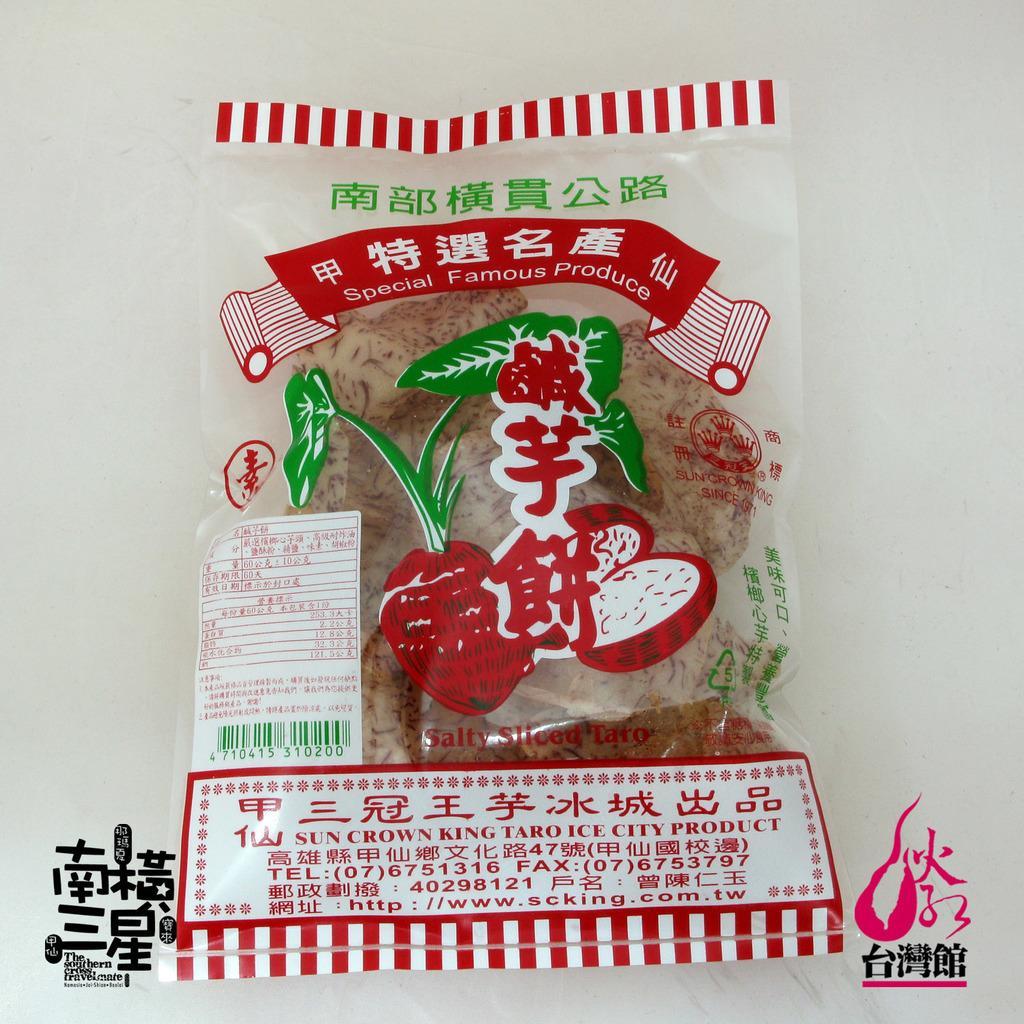How would you summarize this image in a sentence or two? In this picture we can see food packed in a cover. At the bottom portion of the picture we can see watermarks. On the cover we can see the information. 